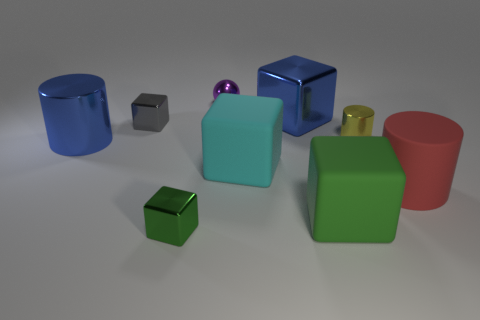Which objects in this image could potentially be containers? In this image, the two objects that could potentially serve as containers are the blue cylinder and the red cylinder due to their hollow and open-topped shapes. 